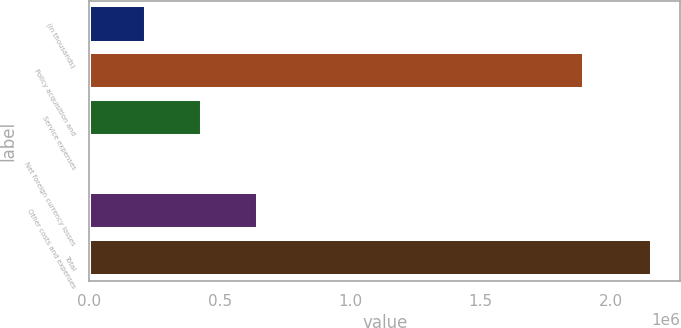Convert chart. <chart><loc_0><loc_0><loc_500><loc_500><bar_chart><fcel>(In thousands)<fcel>Policy acquisition and<fcel>Service expenses<fcel>Net foreign currency losses<fcel>Other costs and expenses<fcel>Total<nl><fcel>215770<fcel>1.89653e+06<fcel>431513<fcel>27<fcel>647256<fcel>2.15746e+06<nl></chart> 